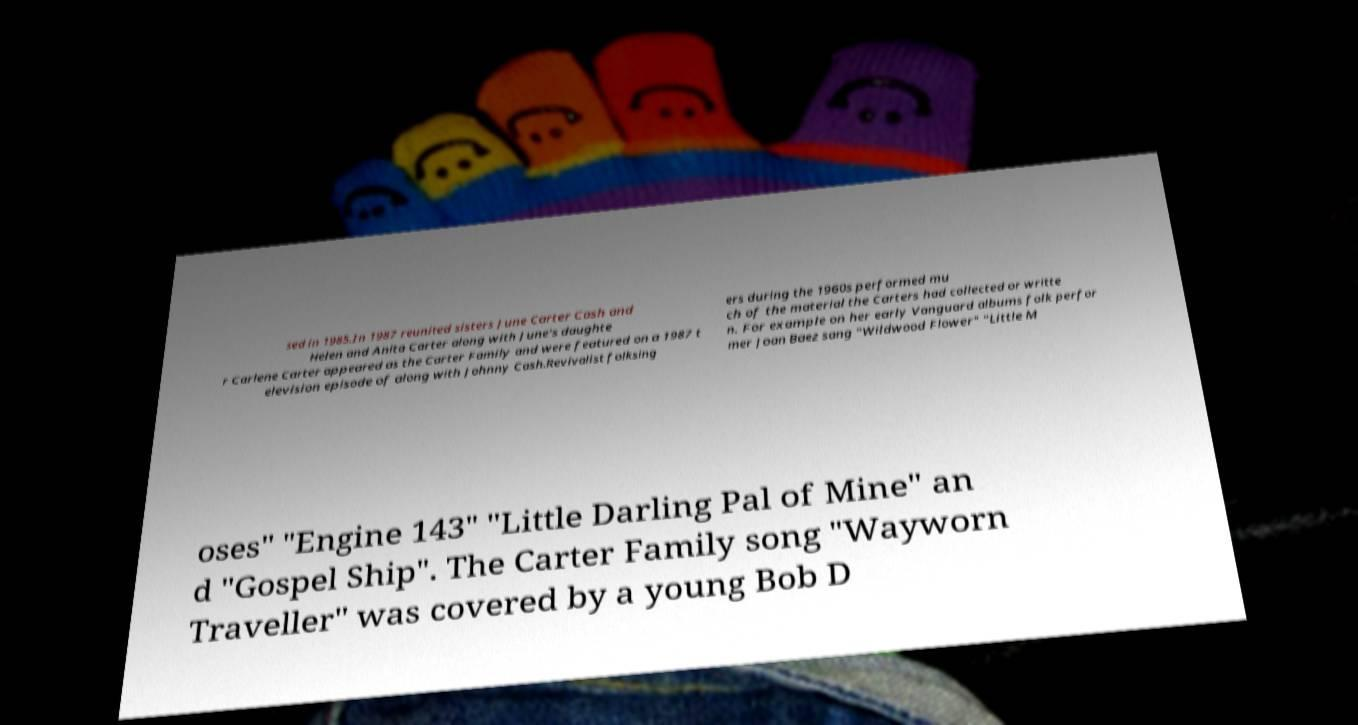For documentation purposes, I need the text within this image transcribed. Could you provide that? sed in 1985.In 1987 reunited sisters June Carter Cash and Helen and Anita Carter along with June's daughte r Carlene Carter appeared as the Carter Family and were featured on a 1987 t elevision episode of along with Johnny Cash.Revivalist folksing ers during the 1960s performed mu ch of the material the Carters had collected or writte n. For example on her early Vanguard albums folk perfor mer Joan Baez sang "Wildwood Flower" "Little M oses" "Engine 143" "Little Darling Pal of Mine" an d "Gospel Ship". The Carter Family song "Wayworn Traveller" was covered by a young Bob D 